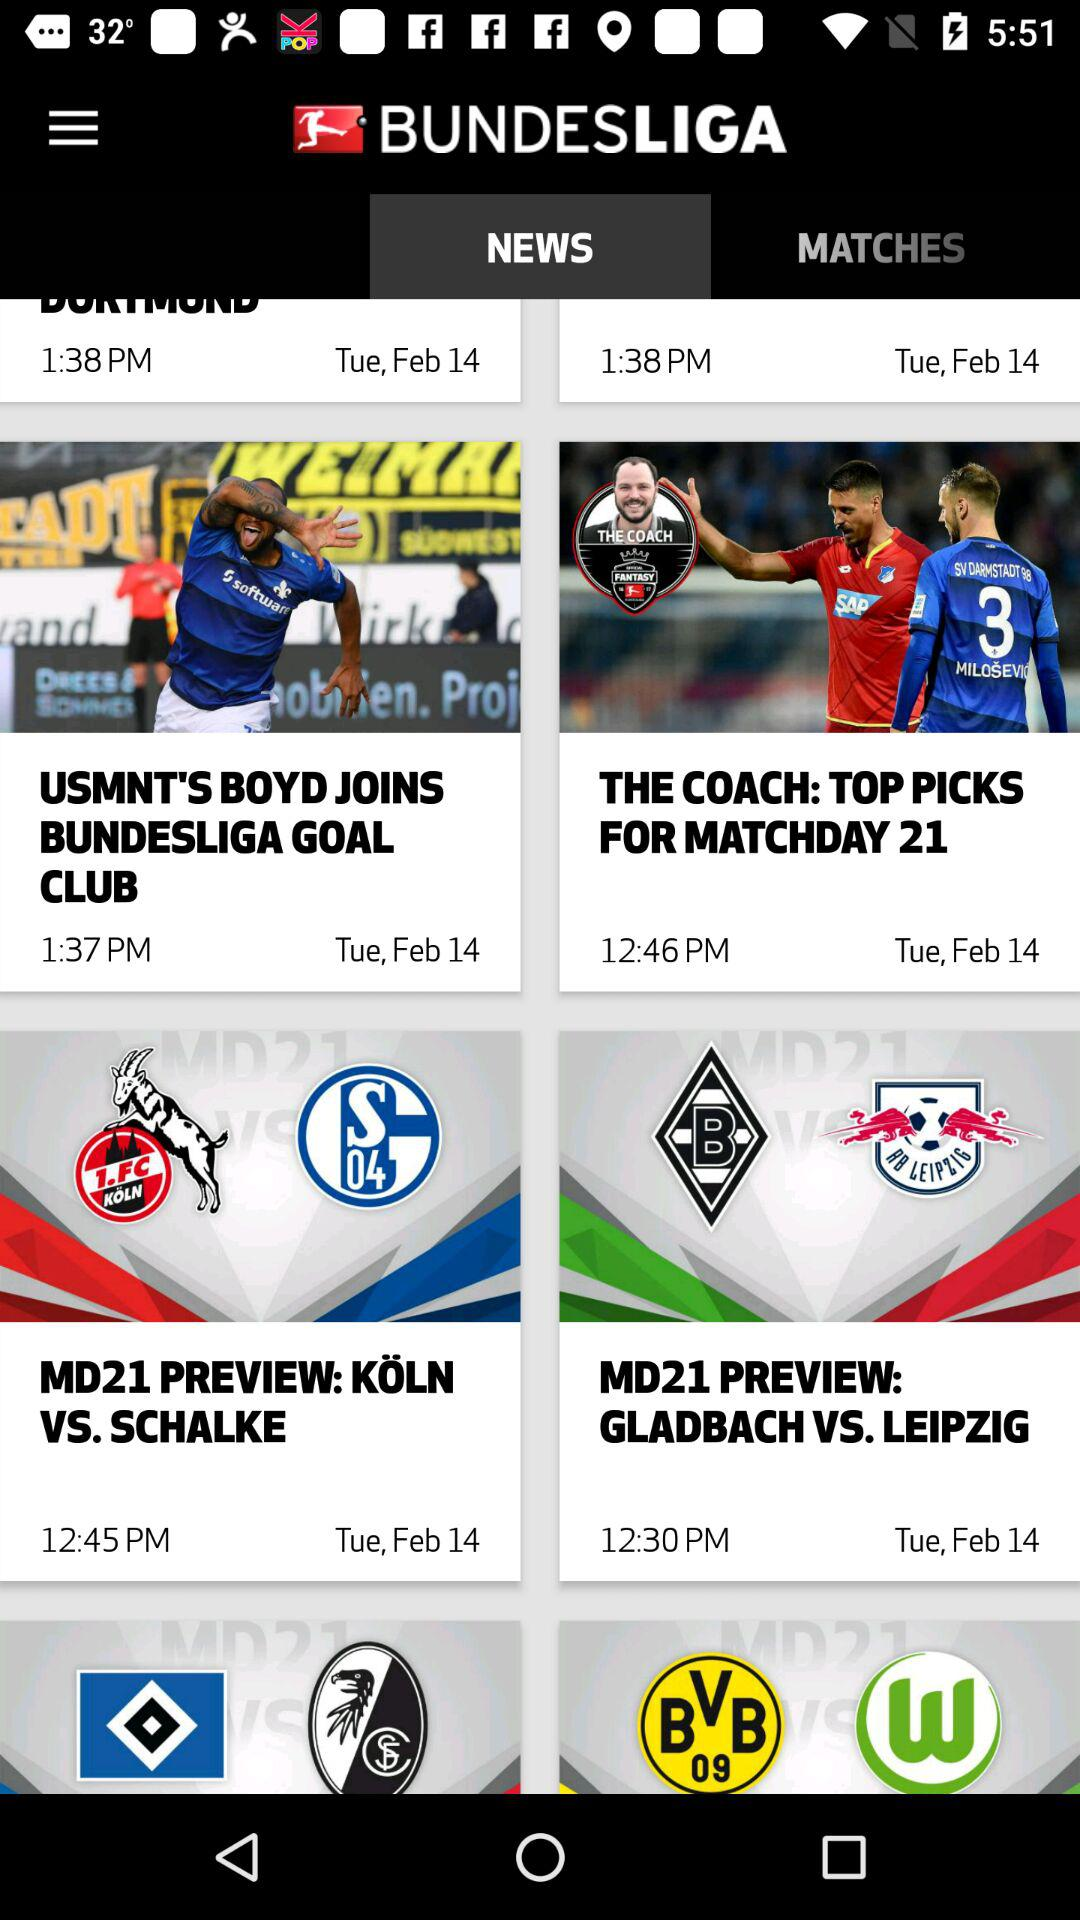What is the name of the application? The name of the application is "BUNDESLIGA". 